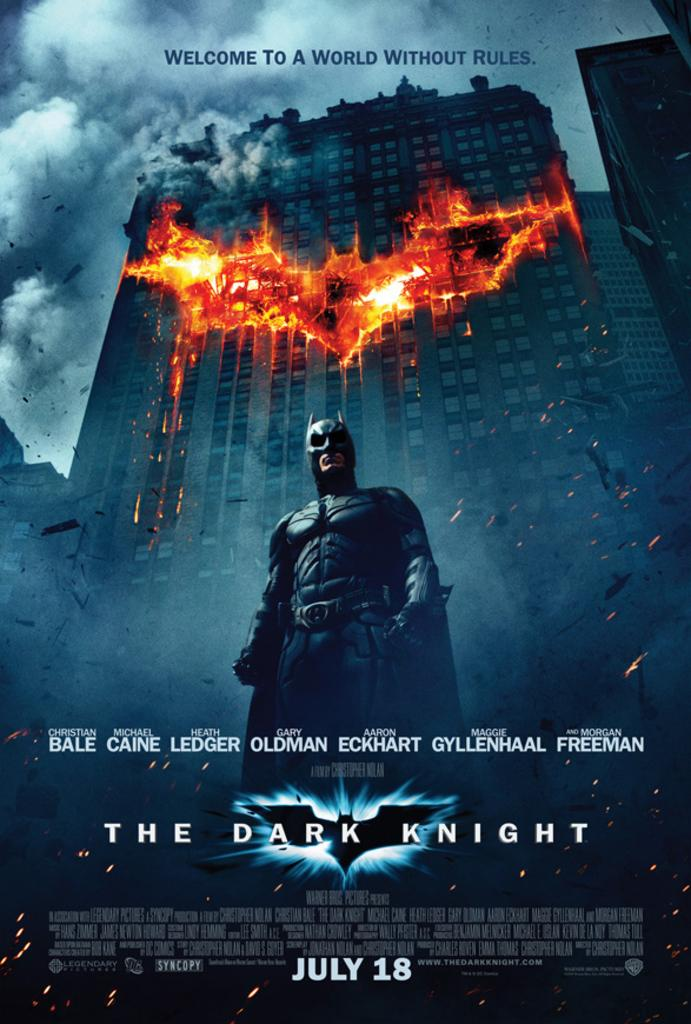<image>
Offer a succinct explanation of the picture presented. Poster for a movie showing a superhero on the front and the name "The Dark Knight". 